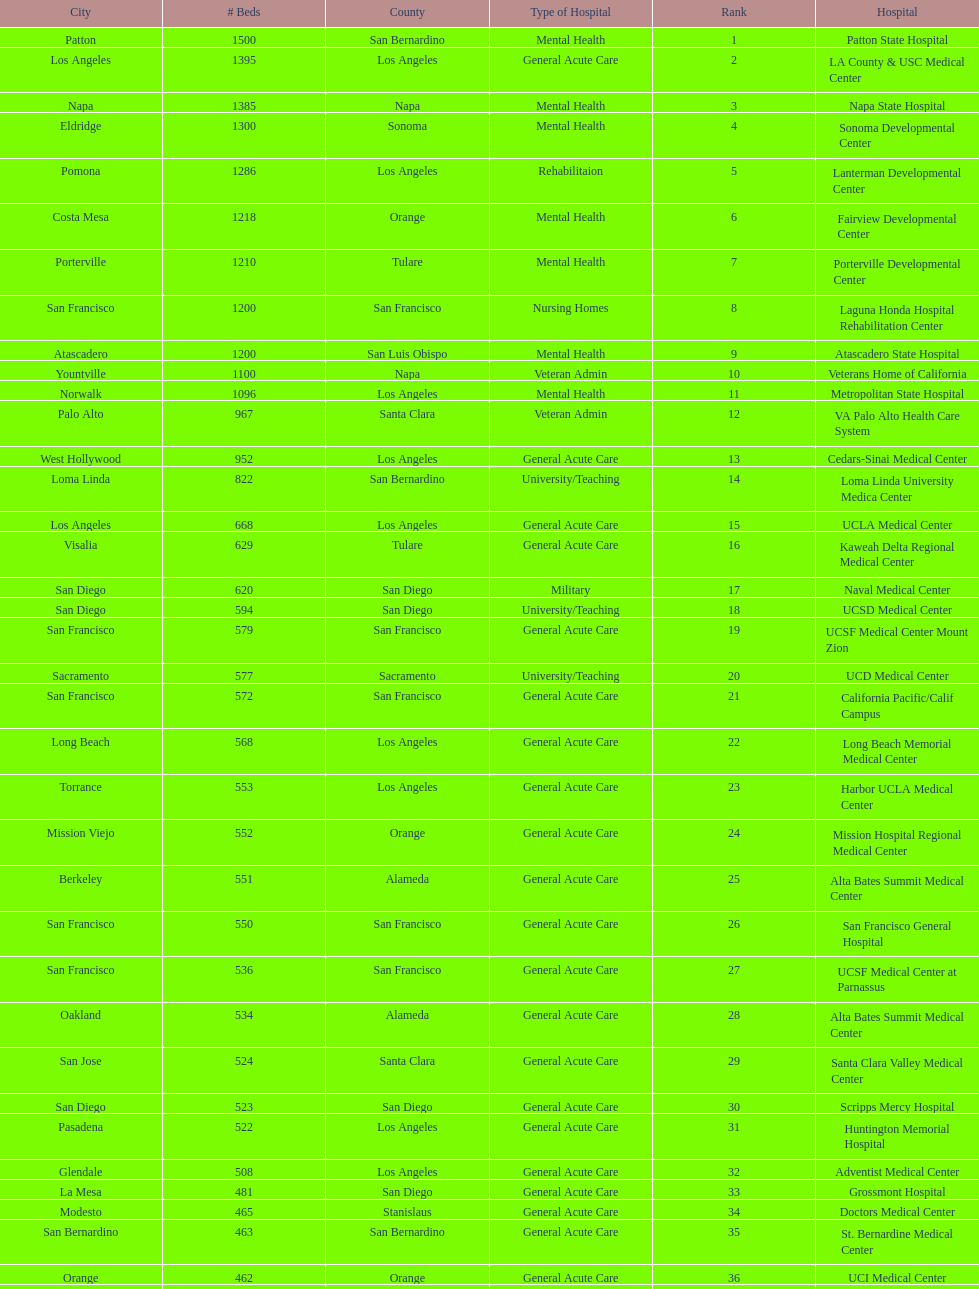How many more general acute care hospitals are there in california than rehabilitation hospitals? 33. Parse the full table. {'header': ['City', '# Beds', 'County', 'Type of Hospital', 'Rank', 'Hospital'], 'rows': [['Patton', '1500', 'San Bernardino', 'Mental Health', '1', 'Patton State Hospital'], ['Los Angeles', '1395', 'Los Angeles', 'General Acute Care', '2', 'LA County & USC Medical Center'], ['Napa', '1385', 'Napa', 'Mental Health', '3', 'Napa State Hospital'], ['Eldridge', '1300', 'Sonoma', 'Mental Health', '4', 'Sonoma Developmental Center'], ['Pomona', '1286', 'Los Angeles', 'Rehabilitaion', '5', 'Lanterman Developmental Center'], ['Costa Mesa', '1218', 'Orange', 'Mental Health', '6', 'Fairview Developmental Center'], ['Porterville', '1210', 'Tulare', 'Mental Health', '7', 'Porterville Developmental Center'], ['San Francisco', '1200', 'San Francisco', 'Nursing Homes', '8', 'Laguna Honda Hospital Rehabilitation Center'], ['Atascadero', '1200', 'San Luis Obispo', 'Mental Health', '9', 'Atascadero State Hospital'], ['Yountville', '1100', 'Napa', 'Veteran Admin', '10', 'Veterans Home of California'], ['Norwalk', '1096', 'Los Angeles', 'Mental Health', '11', 'Metropolitan State Hospital'], ['Palo Alto', '967', 'Santa Clara', 'Veteran Admin', '12', 'VA Palo Alto Health Care System'], ['West Hollywood', '952', 'Los Angeles', 'General Acute Care', '13', 'Cedars-Sinai Medical Center'], ['Loma Linda', '822', 'San Bernardino', 'University/Teaching', '14', 'Loma Linda University Medica Center'], ['Los Angeles', '668', 'Los Angeles', 'General Acute Care', '15', 'UCLA Medical Center'], ['Visalia', '629', 'Tulare', 'General Acute Care', '16', 'Kaweah Delta Regional Medical Center'], ['San Diego', '620', 'San Diego', 'Military', '17', 'Naval Medical Center'], ['San Diego', '594', 'San Diego', 'University/Teaching', '18', 'UCSD Medical Center'], ['San Francisco', '579', 'San Francisco', 'General Acute Care', '19', 'UCSF Medical Center Mount Zion'], ['Sacramento', '577', 'Sacramento', 'University/Teaching', '20', 'UCD Medical Center'], ['San Francisco', '572', 'San Francisco', 'General Acute Care', '21', 'California Pacific/Calif Campus'], ['Long Beach', '568', 'Los Angeles', 'General Acute Care', '22', 'Long Beach Memorial Medical Center'], ['Torrance', '553', 'Los Angeles', 'General Acute Care', '23', 'Harbor UCLA Medical Center'], ['Mission Viejo', '552', 'Orange', 'General Acute Care', '24', 'Mission Hospital Regional Medical Center'], ['Berkeley', '551', 'Alameda', 'General Acute Care', '25', 'Alta Bates Summit Medical Center'], ['San Francisco', '550', 'San Francisco', 'General Acute Care', '26', 'San Francisco General Hospital'], ['San Francisco', '536', 'San Francisco', 'General Acute Care', '27', 'UCSF Medical Center at Parnassus'], ['Oakland', '534', 'Alameda', 'General Acute Care', '28', 'Alta Bates Summit Medical Center'], ['San Jose', '524', 'Santa Clara', 'General Acute Care', '29', 'Santa Clara Valley Medical Center'], ['San Diego', '523', 'San Diego', 'General Acute Care', '30', 'Scripps Mercy Hospital'], ['Pasadena', '522', 'Los Angeles', 'General Acute Care', '31', 'Huntington Memorial Hospital'], ['Glendale', '508', 'Los Angeles', 'General Acute Care', '32', 'Adventist Medical Center'], ['La Mesa', '481', 'San Diego', 'General Acute Care', '33', 'Grossmont Hospital'], ['Modesto', '465', 'Stanislaus', 'General Acute Care', '34', 'Doctors Medical Center'], ['San Bernardino', '463', 'San Bernardino', 'General Acute Care', '35', 'St. Bernardine Medical Center'], ['Orange', '462', 'Orange', 'General Acute Care', '36', 'UCI Medical Center'], ['Stanford', '460', 'Santa Clara', 'General Acute Care', '37', 'Stanford Medical Center'], ['Fresno', '457', 'Fresno', 'General Acute Care', '38', 'Community Regional Medical Center'], ['Arcadia', '455', 'Los Angeles', 'General Acute Care', '39', 'Methodist Hospital'], ['Burbank', '455', 'Los Angeles', 'General Acute Care', '40', 'Providence St. Joseph Medical Center'], ['Newport Beach', '450', 'Orange', 'General Acute Care', '41', 'Hoag Memorial Hospital'], ['San Jose', '450', 'Santa Clara', 'Mental Health', '42', 'Agnews Developmental Center'], ['San Francisco', '450', 'San Francisco', 'Nursing Homes', '43', 'Jewish Home'], ['Orange', '448', 'Orange', 'General Acute Care', '44', 'St. Joseph Hospital Orange'], ['Whittier', '441', 'Los Angeles', 'General Acute Care', '45', 'Presbyterian Intercommunity'], ['Fontana', '440', 'San Bernardino', 'General Acute Care', '46', 'Kaiser Permanente Medical Center'], ['Los Angeles', '439', 'Los Angeles', 'General Acute Care', '47', 'Kaiser Permanente Medical Center'], ['Pomona', '436', 'Los Angeles', 'General Acute Care', '48', 'Pomona Valley Hospital Medical Center'], ['Sacramento', '432', 'Sacramento', 'General Acute Care', '49', 'Sutter General Medical Center'], ['San Francisco', '430', 'San Francisco', 'General Acute Care', '50', 'St. Mary Medical Center'], ['San Jose', '429', 'Santa Clara', 'General Acute Care', '50', 'Good Samaritan Hospital']]} 